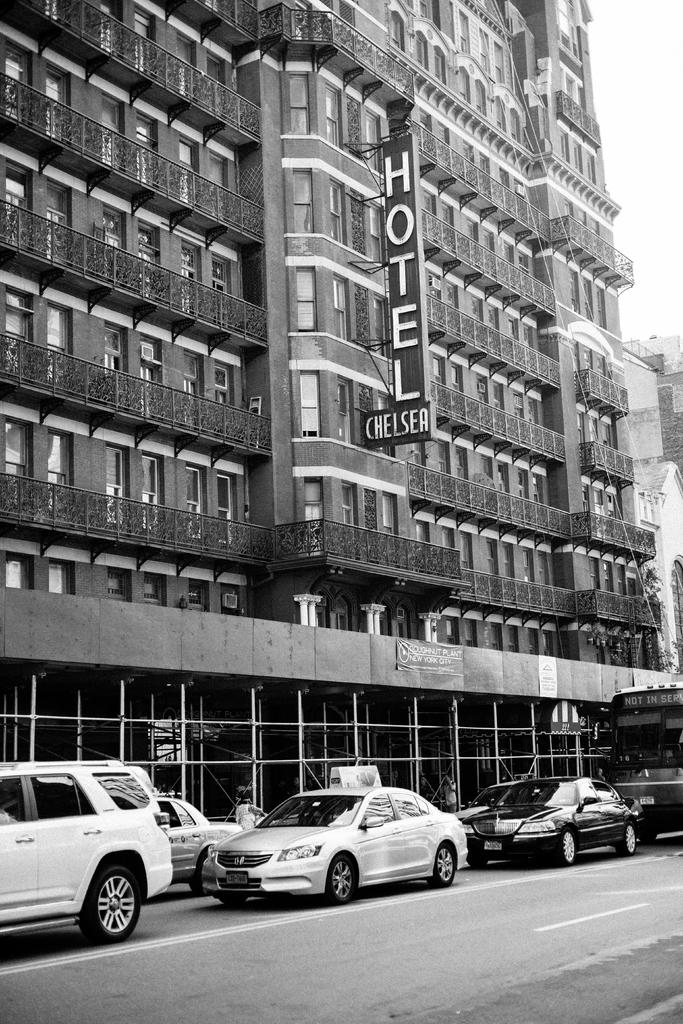What is the color scheme of the image? The image is black and white. What type of structure is present in the image? There is a building in the image. What is covering the building? The building has hoarding. Are there any additional signs or advertisements in the image? Yes, there are banners in the image. What type of windows does the building have? The building has glass windows. What else can be seen in the image? Vehicles are visible on the road in the image. Reasoning: Let's think step by step by step in order to produce the conversation. We start by identifying the color scheme of the image, which is black and white. Then, we focus on the main subject, which is the building. We describe its features, such as the hoarding and glass windows, and mention the presence of banners. Finally, we acknowledge the presence of vehicles on the road to provide a sense of the setting. Absurd Question/Answer: What type of bubble can be seen floating near the building in the image? There is no bubble present in the image. How many chairs are visible in the image? There are no chairs visible in the image. 